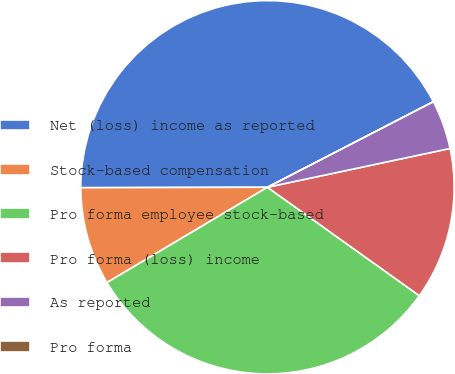<chart> <loc_0><loc_0><loc_500><loc_500><pie_chart><fcel>Net (loss) income as reported<fcel>Stock-based compensation<fcel>Pro forma employee stock-based<fcel>Pro forma (loss) income<fcel>As reported<fcel>Pro forma<nl><fcel>42.46%<fcel>8.49%<fcel>31.6%<fcel>13.2%<fcel>4.25%<fcel>0.0%<nl></chart> 